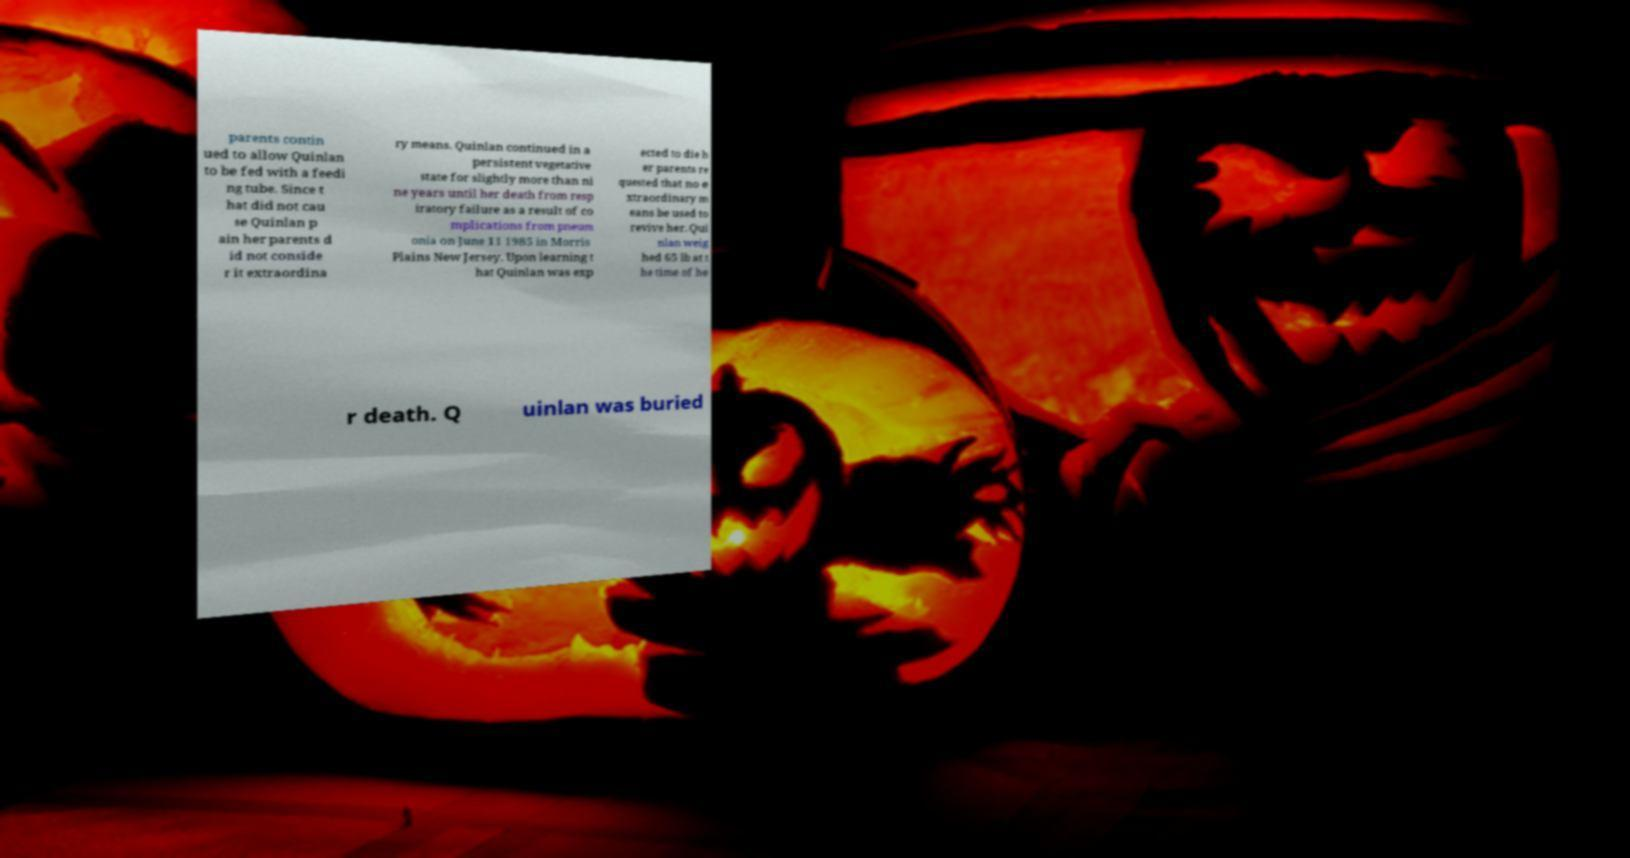Could you assist in decoding the text presented in this image and type it out clearly? parents contin ued to allow Quinlan to be fed with a feedi ng tube. Since t hat did not cau se Quinlan p ain her parents d id not conside r it extraordina ry means. Quinlan continued in a persistent vegetative state for slightly more than ni ne years until her death from resp iratory failure as a result of co mplications from pneum onia on June 11 1985 in Morris Plains New Jersey. Upon learning t hat Quinlan was exp ected to die h er parents re quested that no e xtraordinary m eans be used to revive her. Qui nlan weig hed 65 lb at t he time of he r death. Q uinlan was buried 